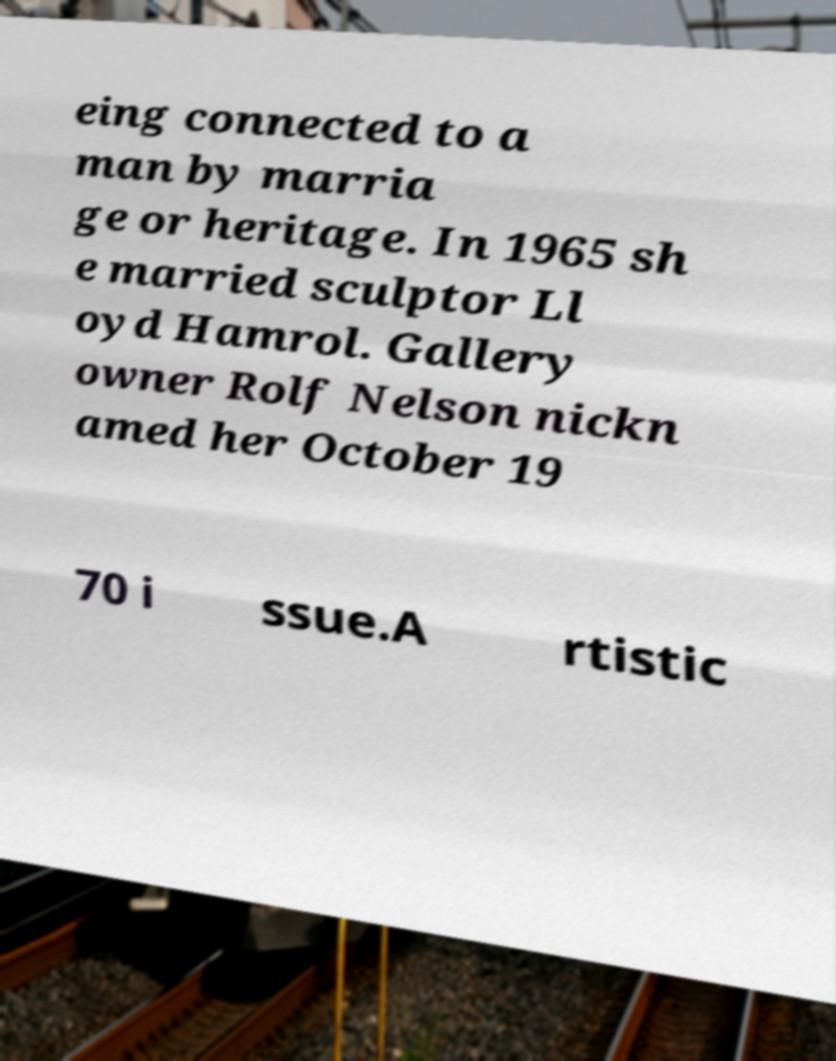There's text embedded in this image that I need extracted. Can you transcribe it verbatim? eing connected to a man by marria ge or heritage. In 1965 sh e married sculptor Ll oyd Hamrol. Gallery owner Rolf Nelson nickn amed her October 19 70 i ssue.A rtistic 